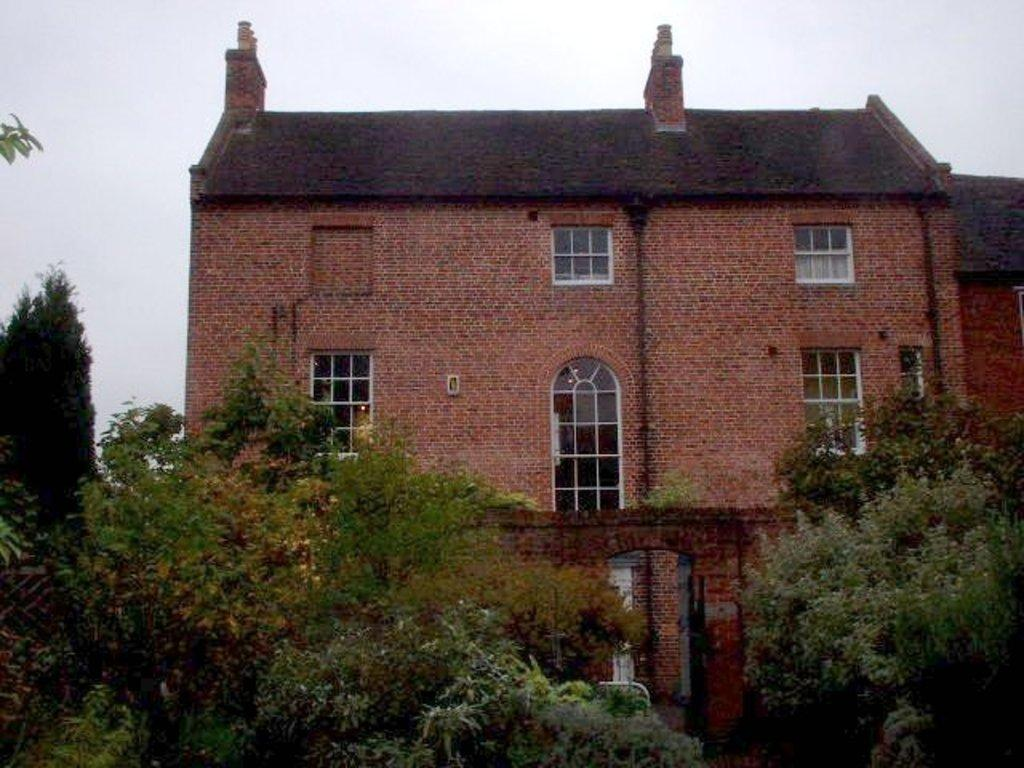What type of vegetation is at the bottom of the picture? There are trees at the bottom of the picture. What structure can be seen in the background of the picture? There is a building in the background of the picture. What material is the building made of? The building is made up of brown colored bricks. What is visible at the top of the picture? The sky is visible at the top of the picture. How many eyes can be seen on the flag in the image? There is no flag present in the image, so there are no eyes to count. What type of bed is visible in the image? There is no bed present in the image. 